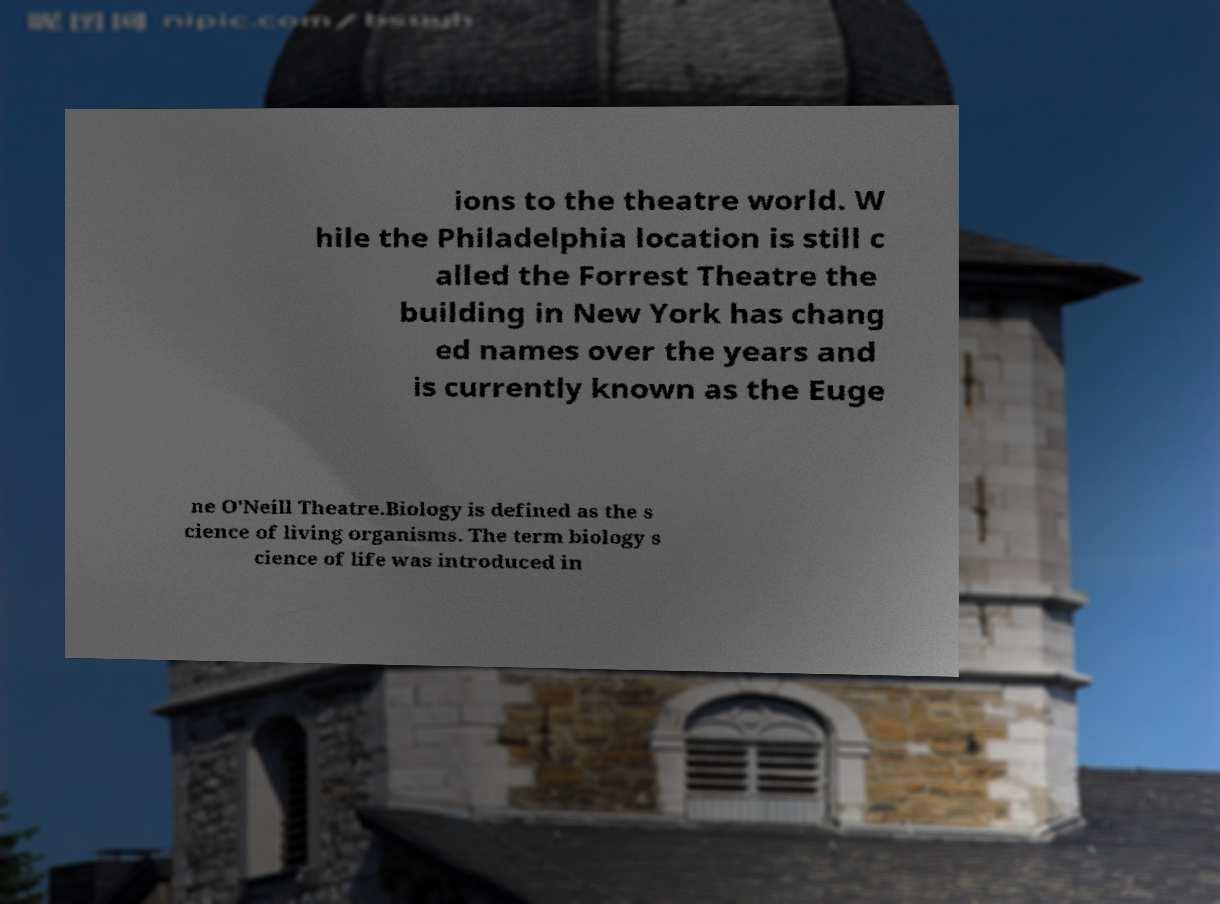For documentation purposes, I need the text within this image transcribed. Could you provide that? ions to the theatre world. W hile the Philadelphia location is still c alled the Forrest Theatre the building in New York has chang ed names over the years and is currently known as the Euge ne O'Neill Theatre.Biology is defined as the s cience of living organisms. The term biology s cience of life was introduced in 